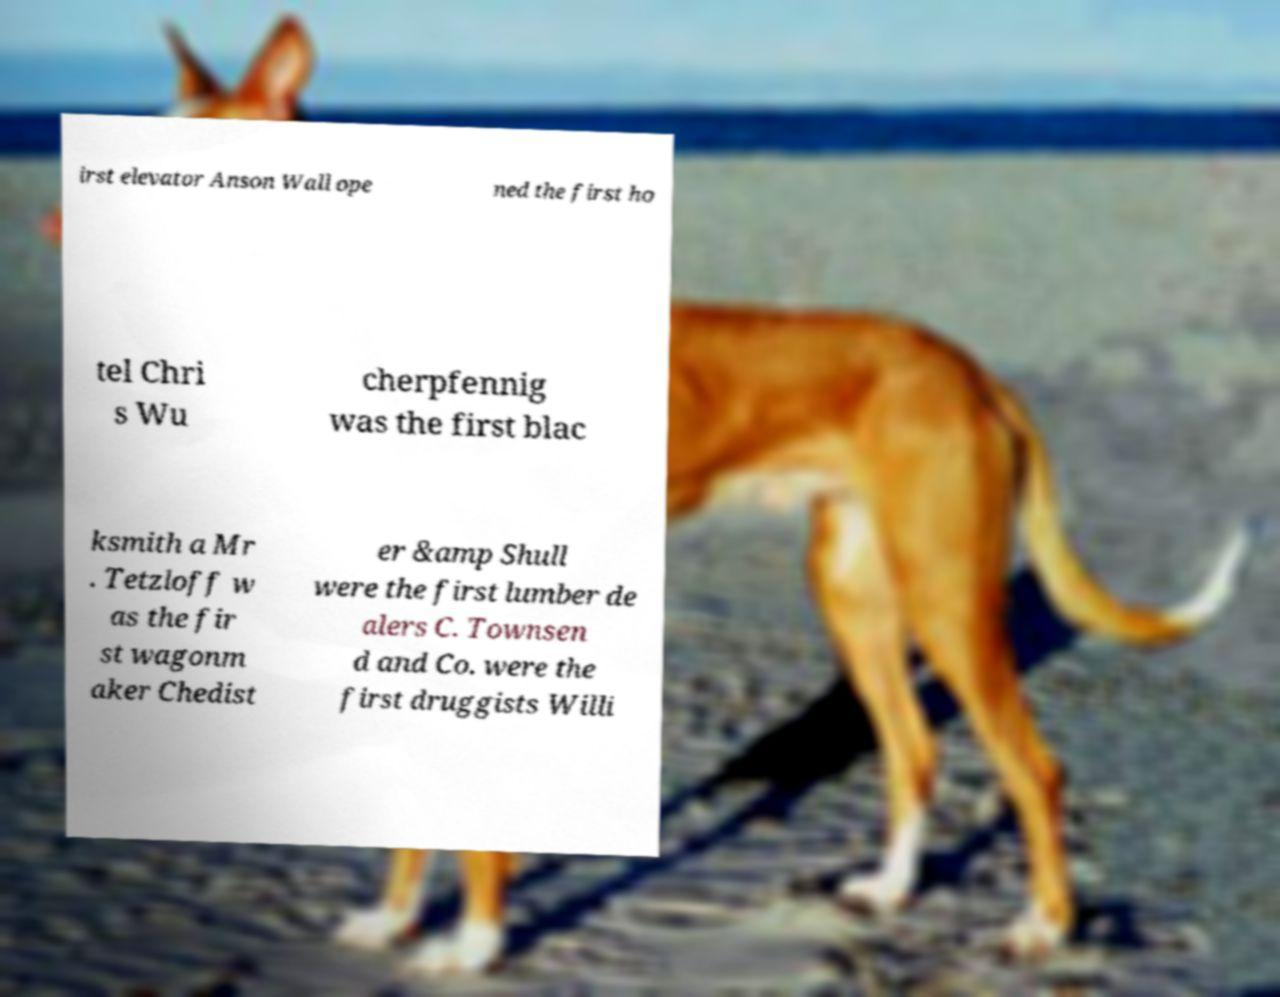For documentation purposes, I need the text within this image transcribed. Could you provide that? irst elevator Anson Wall ope ned the first ho tel Chri s Wu cherpfennig was the first blac ksmith a Mr . Tetzloff w as the fir st wagonm aker Chedist er &amp Shull were the first lumber de alers C. Townsen d and Co. were the first druggists Willi 